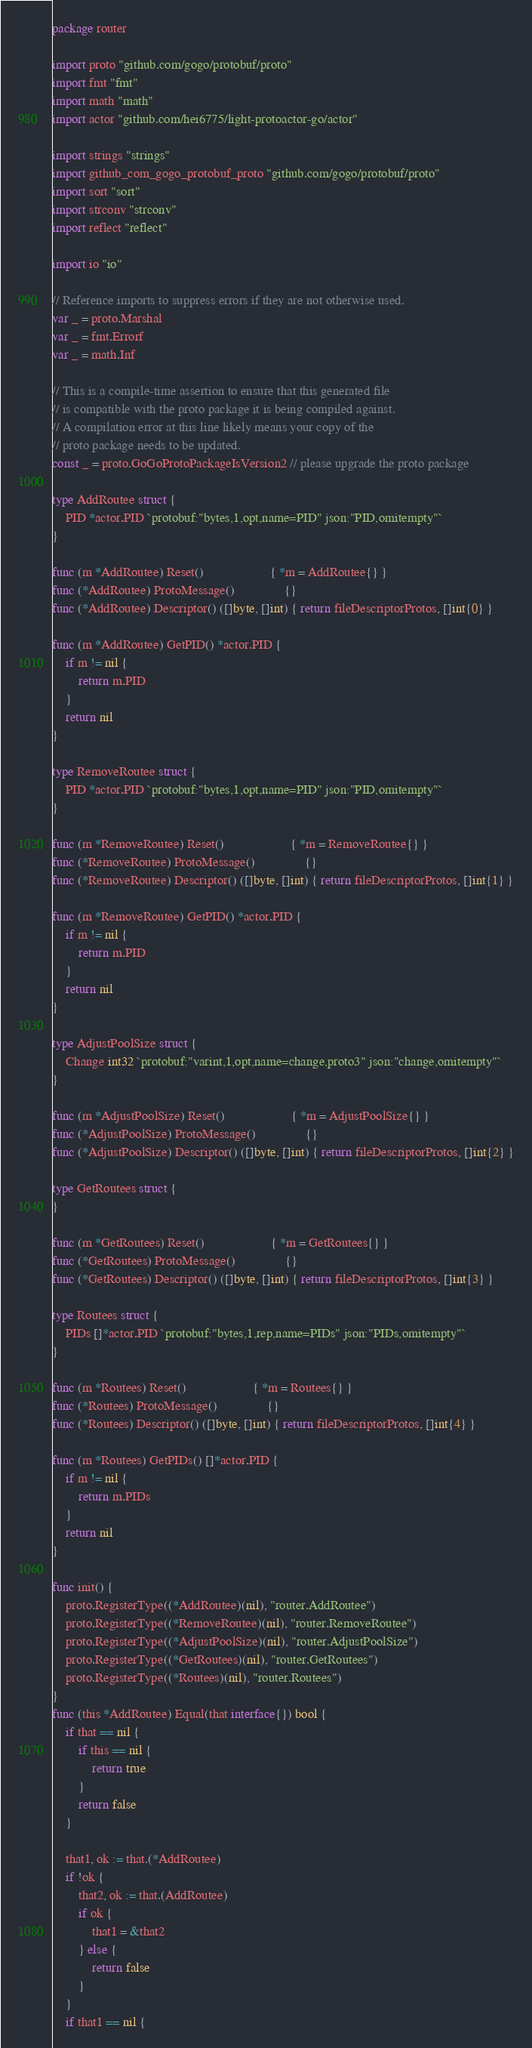Convert code to text. <code><loc_0><loc_0><loc_500><loc_500><_Go_>package router

import proto "github.com/gogo/protobuf/proto"
import fmt "fmt"
import math "math"
import actor "github.com/hei6775/light-protoactor-go/actor"

import strings "strings"
import github_com_gogo_protobuf_proto "github.com/gogo/protobuf/proto"
import sort "sort"
import strconv "strconv"
import reflect "reflect"

import io "io"

// Reference imports to suppress errors if they are not otherwise used.
var _ = proto.Marshal
var _ = fmt.Errorf
var _ = math.Inf

// This is a compile-time assertion to ensure that this generated file
// is compatible with the proto package it is being compiled against.
// A compilation error at this line likely means your copy of the
// proto package needs to be updated.
const _ = proto.GoGoProtoPackageIsVersion2 // please upgrade the proto package

type AddRoutee struct {
	PID *actor.PID `protobuf:"bytes,1,opt,name=PID" json:"PID,omitempty"`
}

func (m *AddRoutee) Reset()                    { *m = AddRoutee{} }
func (*AddRoutee) ProtoMessage()               {}
func (*AddRoutee) Descriptor() ([]byte, []int) { return fileDescriptorProtos, []int{0} }

func (m *AddRoutee) GetPID() *actor.PID {
	if m != nil {
		return m.PID
	}
	return nil
}

type RemoveRoutee struct {
	PID *actor.PID `protobuf:"bytes,1,opt,name=PID" json:"PID,omitempty"`
}

func (m *RemoveRoutee) Reset()                    { *m = RemoveRoutee{} }
func (*RemoveRoutee) ProtoMessage()               {}
func (*RemoveRoutee) Descriptor() ([]byte, []int) { return fileDescriptorProtos, []int{1} }

func (m *RemoveRoutee) GetPID() *actor.PID {
	if m != nil {
		return m.PID
	}
	return nil
}

type AdjustPoolSize struct {
	Change int32 `protobuf:"varint,1,opt,name=change,proto3" json:"change,omitempty"`
}

func (m *AdjustPoolSize) Reset()                    { *m = AdjustPoolSize{} }
func (*AdjustPoolSize) ProtoMessage()               {}
func (*AdjustPoolSize) Descriptor() ([]byte, []int) { return fileDescriptorProtos, []int{2} }

type GetRoutees struct {
}

func (m *GetRoutees) Reset()                    { *m = GetRoutees{} }
func (*GetRoutees) ProtoMessage()               {}
func (*GetRoutees) Descriptor() ([]byte, []int) { return fileDescriptorProtos, []int{3} }

type Routees struct {
	PIDs []*actor.PID `protobuf:"bytes,1,rep,name=PIDs" json:"PIDs,omitempty"`
}

func (m *Routees) Reset()                    { *m = Routees{} }
func (*Routees) ProtoMessage()               {}
func (*Routees) Descriptor() ([]byte, []int) { return fileDescriptorProtos, []int{4} }

func (m *Routees) GetPIDs() []*actor.PID {
	if m != nil {
		return m.PIDs
	}
	return nil
}

func init() {
	proto.RegisterType((*AddRoutee)(nil), "router.AddRoutee")
	proto.RegisterType((*RemoveRoutee)(nil), "router.RemoveRoutee")
	proto.RegisterType((*AdjustPoolSize)(nil), "router.AdjustPoolSize")
	proto.RegisterType((*GetRoutees)(nil), "router.GetRoutees")
	proto.RegisterType((*Routees)(nil), "router.Routees")
}
func (this *AddRoutee) Equal(that interface{}) bool {
	if that == nil {
		if this == nil {
			return true
		}
		return false
	}

	that1, ok := that.(*AddRoutee)
	if !ok {
		that2, ok := that.(AddRoutee)
		if ok {
			that1 = &that2
		} else {
			return false
		}
	}
	if that1 == nil {</code> 